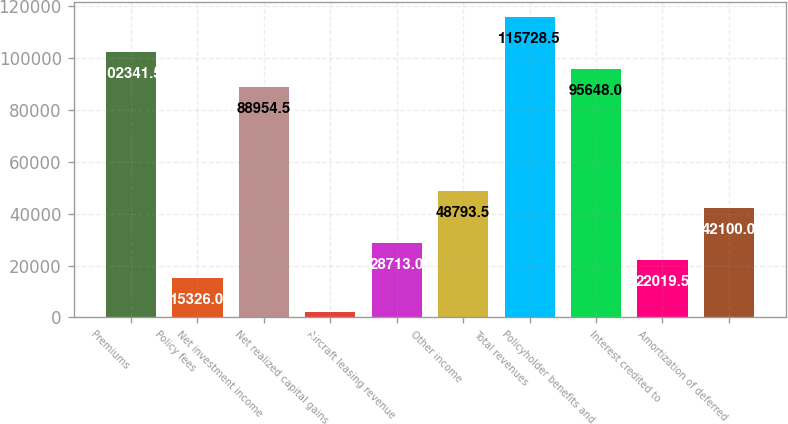Convert chart. <chart><loc_0><loc_0><loc_500><loc_500><bar_chart><fcel>Premiums<fcel>Policy fees<fcel>Net investment income<fcel>Net realized capital gains<fcel>Aircraft leasing revenue<fcel>Other income<fcel>Total revenues<fcel>Policyholder benefits and<fcel>Interest credited to<fcel>Amortization of deferred<nl><fcel>102342<fcel>15326<fcel>88954.5<fcel>1939<fcel>28713<fcel>48793.5<fcel>115728<fcel>95648<fcel>22019.5<fcel>42100<nl></chart> 